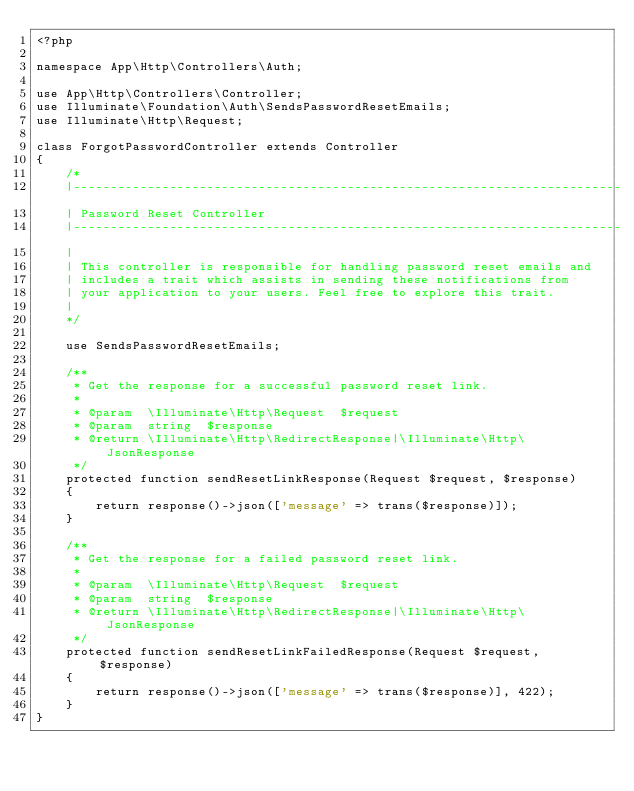Convert code to text. <code><loc_0><loc_0><loc_500><loc_500><_PHP_><?php

namespace App\Http\Controllers\Auth;

use App\Http\Controllers\Controller;
use Illuminate\Foundation\Auth\SendsPasswordResetEmails;
use Illuminate\Http\Request;

class ForgotPasswordController extends Controller
{
    /*
    |--------------------------------------------------------------------------
    | Password Reset Controller
    |--------------------------------------------------------------------------
    |
    | This controller is responsible for handling password reset emails and
    | includes a trait which assists in sending these notifications from
    | your application to your users. Feel free to explore this trait.
    |
    */

    use SendsPasswordResetEmails;

    /**
     * Get the response for a successful password reset link.
     *
     * @param  \Illuminate\Http\Request  $request
     * @param  string  $response
     * @return \Illuminate\Http\RedirectResponse|\Illuminate\Http\JsonResponse
     */
    protected function sendResetLinkResponse(Request $request, $response)
    {
        return response()->json(['message' => trans($response)]);
    }

    /**
     * Get the response for a failed password reset link.
     *
     * @param  \Illuminate\Http\Request  $request
     * @param  string  $response
     * @return \Illuminate\Http\RedirectResponse|\Illuminate\Http\JsonResponse
     */
    protected function sendResetLinkFailedResponse(Request $request, $response)
    {
        return response()->json(['message' => trans($response)], 422);
    }
}
</code> 